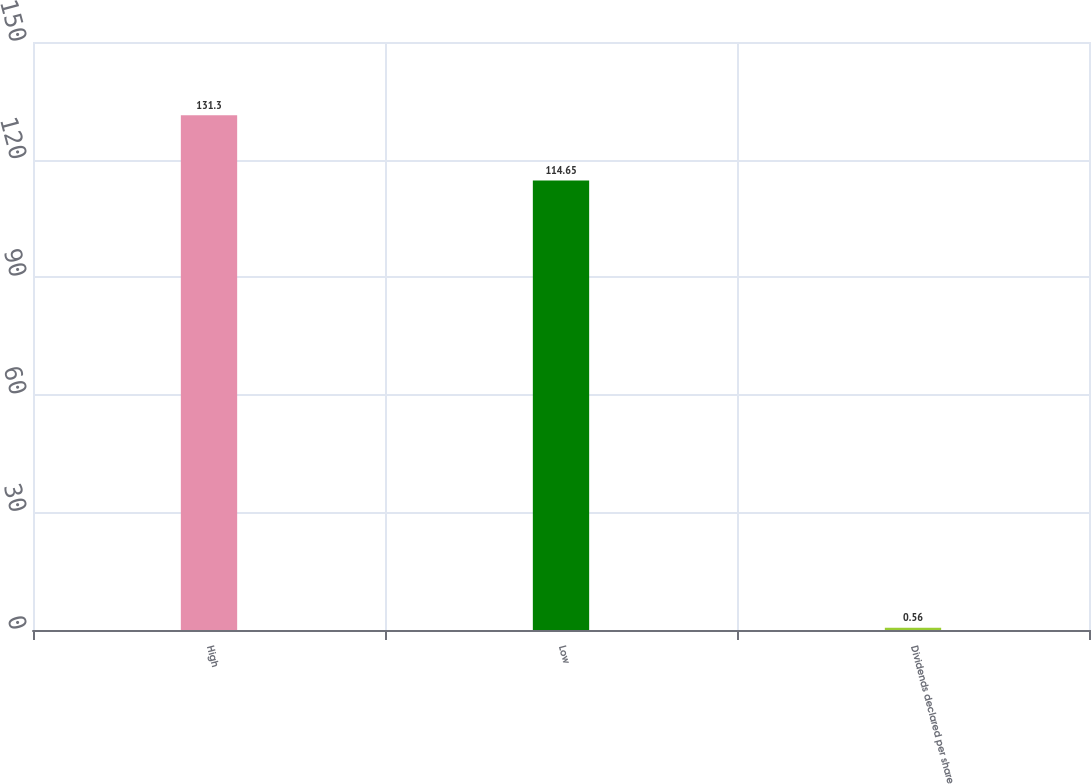<chart> <loc_0><loc_0><loc_500><loc_500><bar_chart><fcel>High<fcel>Low<fcel>Dividends declared per share<nl><fcel>131.3<fcel>114.65<fcel>0.56<nl></chart> 